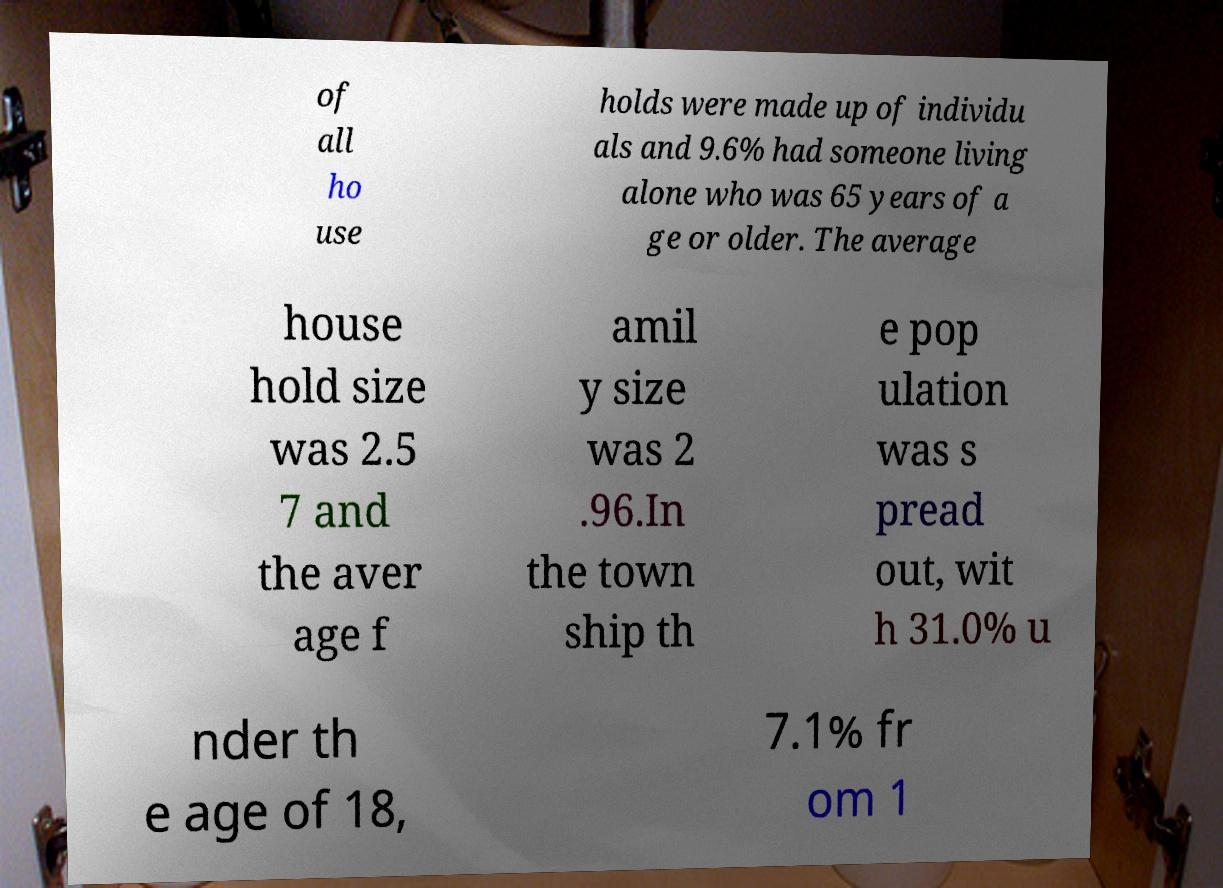What messages or text are displayed in this image? I need them in a readable, typed format. of all ho use holds were made up of individu als and 9.6% had someone living alone who was 65 years of a ge or older. The average house hold size was 2.5 7 and the aver age f amil y size was 2 .96.In the town ship th e pop ulation was s pread out, wit h 31.0% u nder th e age of 18, 7.1% fr om 1 